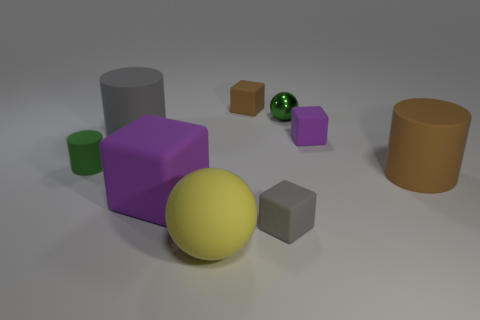Subtract all brown rubber blocks. How many blocks are left? 3 Add 1 green spheres. How many objects exist? 10 Subtract all cyan spheres. How many purple cubes are left? 2 Subtract all gray blocks. How many blocks are left? 3 Add 1 purple matte blocks. How many purple matte blocks exist? 3 Subtract 0 brown balls. How many objects are left? 9 Subtract all cubes. How many objects are left? 5 Subtract 1 cylinders. How many cylinders are left? 2 Subtract all blue cubes. Subtract all yellow spheres. How many cubes are left? 4 Subtract all tiny purple objects. Subtract all big matte blocks. How many objects are left? 7 